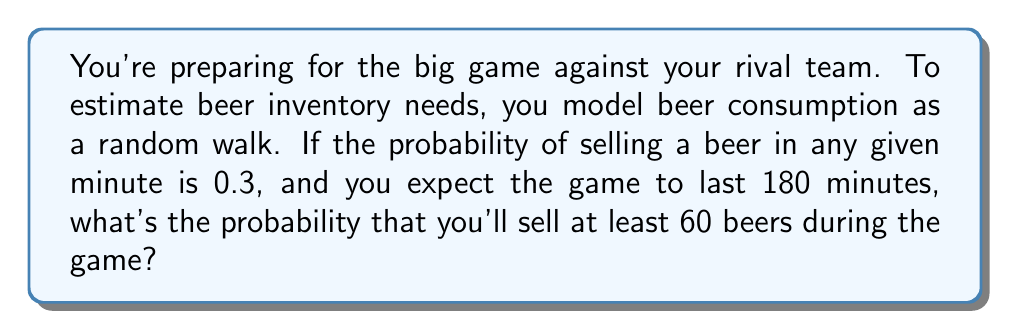Show me your answer to this math problem. Let's approach this step-by-step:

1) This scenario can be modeled as a binomial distribution, where each minute is a trial, and selling a beer is a success.

2) We have:
   - Number of trials (minutes): $n = 180$
   - Probability of success (selling a beer) in each trial: $p = 0.3$
   - We want to find $P(X \geq 60)$, where $X$ is the number of beers sold

3) The mean of this binomial distribution is:
   $\mu = np = 180 \cdot 0.3 = 54$

4) The standard deviation is:
   $\sigma = \sqrt{np(1-p)} = \sqrt{180 \cdot 0.3 \cdot 0.7} = 6.16$

5) Since $n$ is large and $p$ is not too close to 0 or 1, we can approximate the binomial distribution with a normal distribution.

6) We need to apply a continuity correction. Instead of $P(X \geq 60)$, we calculate $P(X > 59.5)$

7) Standardizing, we get:
   $z = \frac{59.5 - 54}{6.16} = 0.89$

8) Now we need to find $P(Z > 0.89)$, where $Z$ is a standard normal variable

9) From the standard normal table, we find:
   $P(Z < 0.89) = 0.8133$

10) Therefore, $P(Z > 0.89) = 1 - 0.8133 = 0.1867$

Thus, the probability of selling at least 60 beers during the game is approximately 0.1867 or 18.67%.
Answer: 0.1867 